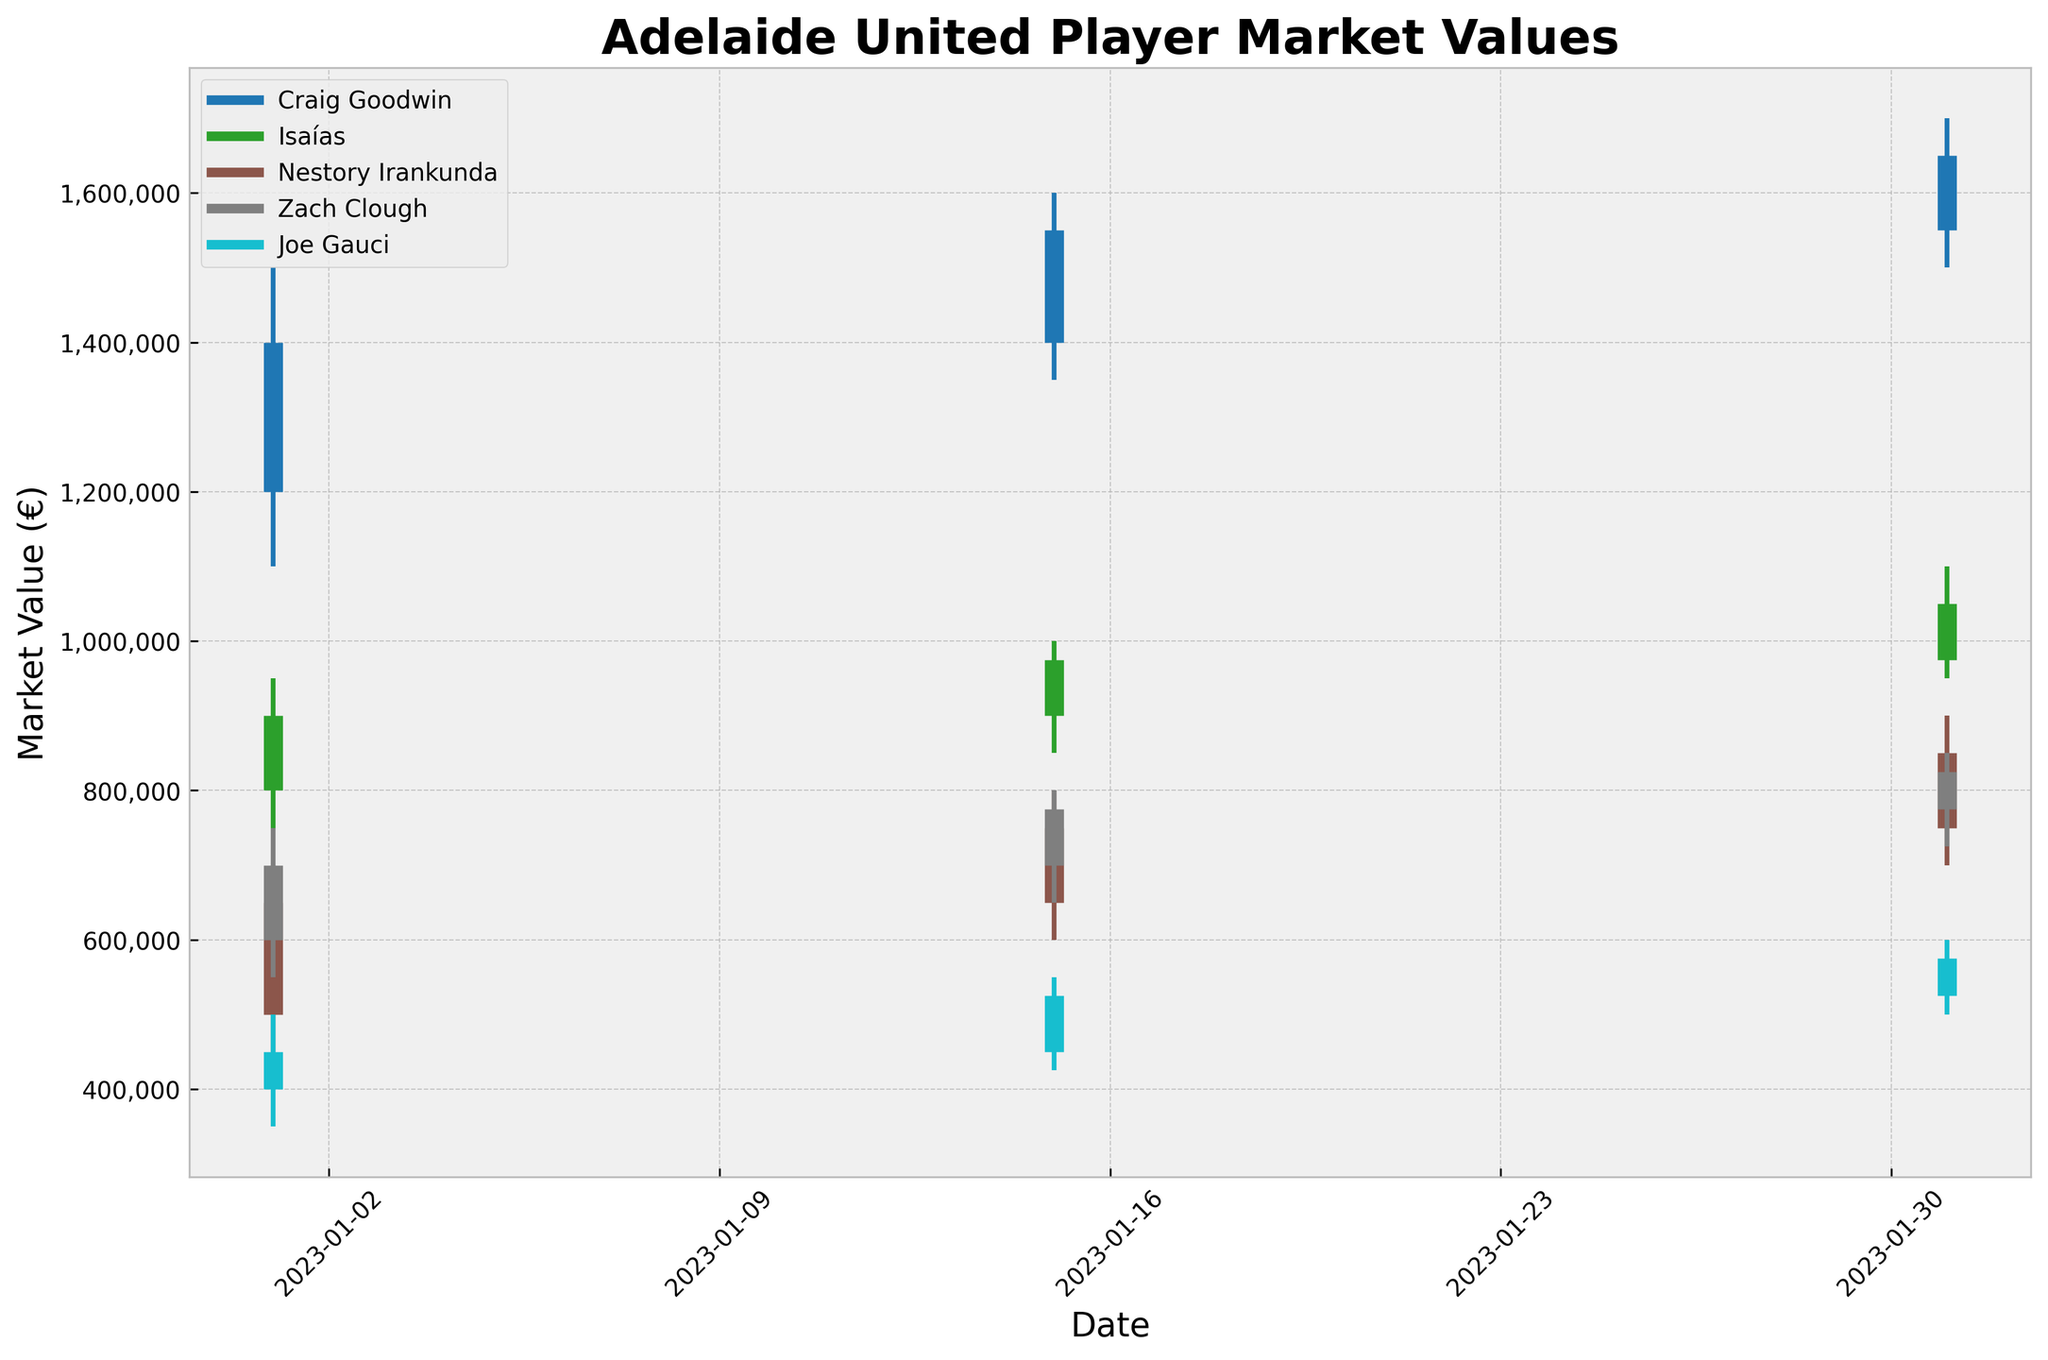What is the title of the chart? The title is displayed at the top of the chart. It helps to know what the chart is about.
Answer: Adelaide United Player Market Values When does the chart show the market values for the players? The x-axis of the chart has dates that span the transfer window, giving insight into the timeframe of the data.
Answer: January 2023 Which player showed the highest market value on January 31, 2023? Look for the highest "High" value on the final date for each player. Craig Goodwin's value reached 1,700,000.
Answer: Craig Goodwin Whose market value had the greatest increase from January 15 to January 31, 2023? Subtract the "Close" value on January 15 from the "Close" value on January 31 for each player. Compare the differences.
Answer: Isaías What is the color used for Craig Goodwin's market value lines? Identify the color corresponding to Craig Goodwin's market value lines in the chart legend.
Answer: Most likely a distinct color like blue (exact shade depends on the plot's color scheme) Whose market value remained between 500,000 and 700,000 throughout January 2023? Scan each player's Low and High values over the month to check if all values fit in the 500,000-700,000 range.
Answer: Joe Gauci What was the lowest market value recorded for any player and on what date? Look for the smallest "Low" value across all players and dates.
Answer: Joe Gauci, January 1, 2023 (350,000) How much did Nestory Irankunda's market value increase from the beginning to the end of January 2023? Subtract the "Open" value on January 1 from the "Close" value on January 31 for Nestory Irankunda.
Answer: 350,000 Which two players had their market value increase consecutively over the three dates? Check the "Close" values for the trends over the three dates for all players.
Answer: Craig Goodwin and Isaías Who experienced the greatest volatility in their market values throughout January 2023? Calculate the difference between the highest "High" and the lowest "Low" values for each player and compare the ranges.
Answer: Craig Goodwin 